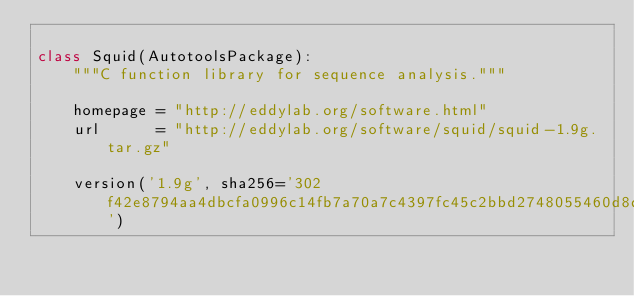<code> <loc_0><loc_0><loc_500><loc_500><_Python_>
class Squid(AutotoolsPackage):
    """C function library for sequence analysis."""

    homepage = "http://eddylab.org/software.html"
    url      = "http://eddylab.org/software/squid/squid-1.9g.tar.gz"

    version('1.9g', sha256='302f42e8794aa4dbcfa0996c14fb7a70a7c4397fc45c2bbd2748055460d8dca7')
</code> 